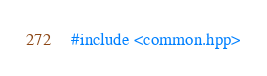Convert code to text. <code><loc_0><loc_0><loc_500><loc_500><_Cuda_>#include <common.hpp></code> 